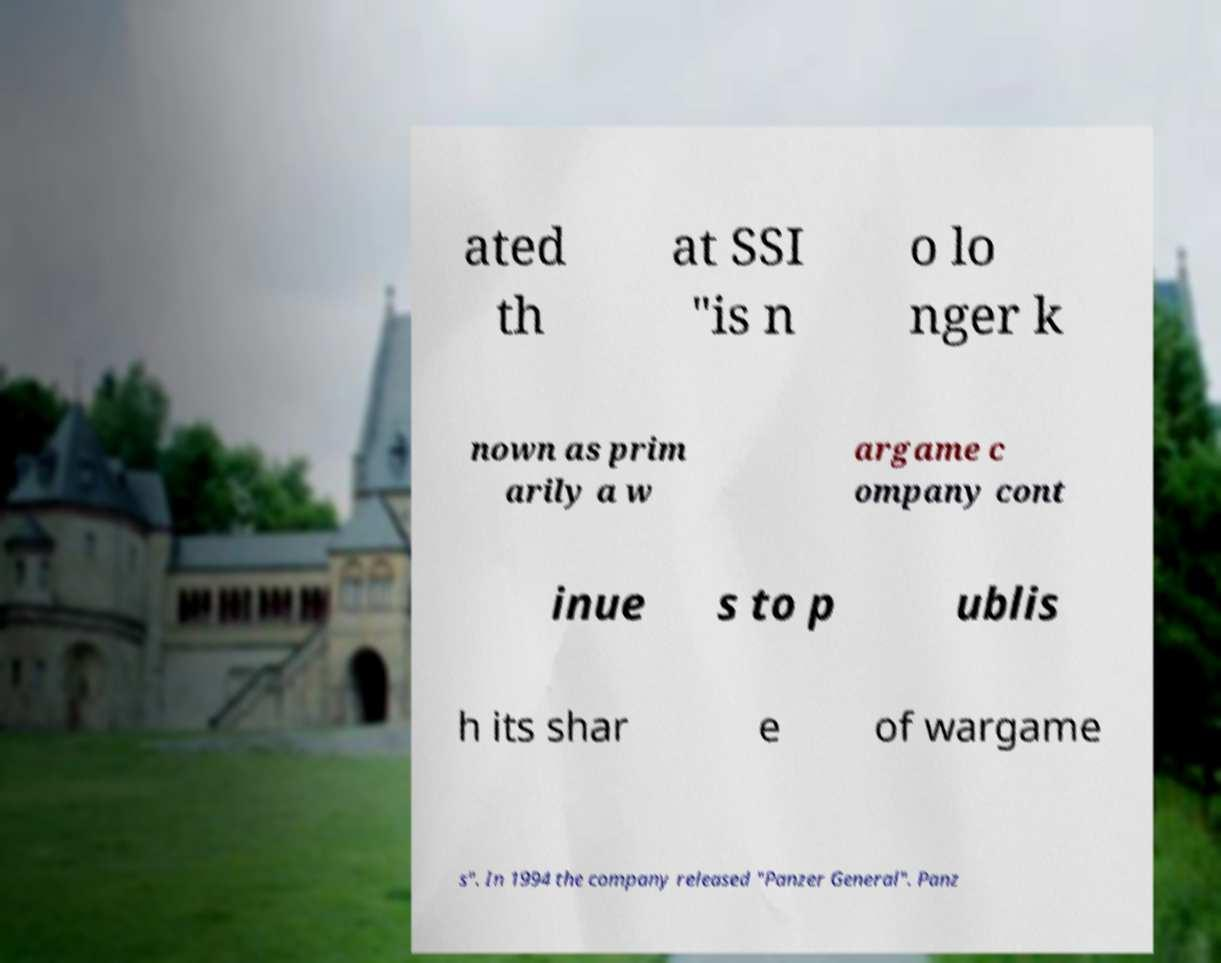Could you extract and type out the text from this image? ated th at SSI "is n o lo nger k nown as prim arily a w argame c ompany cont inue s to p ublis h its shar e of wargame s". In 1994 the company released "Panzer General". Panz 